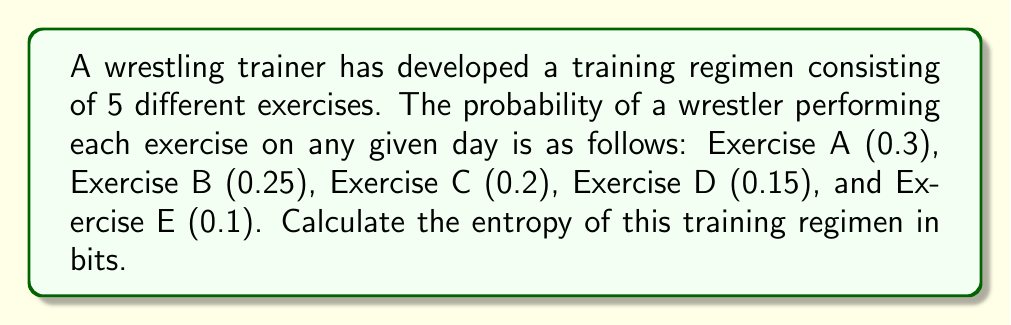Give your solution to this math problem. To calculate the entropy of the training regimen, we'll use the formula for Shannon entropy:

$$ S = -\sum_{i=1}^{n} p_i \log_2(p_i) $$

Where $S$ is the entropy, $p_i$ is the probability of each outcome, and $n$ is the number of possible outcomes.

Step 1: List the probabilities for each exercise:
$p_1 = 0.3$ (Exercise A)
$p_2 = 0.25$ (Exercise B)
$p_3 = 0.2$ (Exercise C)
$p_4 = 0.15$ (Exercise D)
$p_5 = 0.1$ (Exercise E)

Step 2: Calculate $-p_i \log_2(p_i)$ for each exercise:

Exercise A: $-0.3 \log_2(0.3) = 0.3 \times 1.737 = 0.5211$
Exercise B: $-0.25 \log_2(0.25) = 0.25 \times 2 = 0.5000$
Exercise C: $-0.2 \log_2(0.2) = 0.2 \times 2.322 = 0.4644$
Exercise D: $-0.15 \log_2(0.15) = 0.15 \times 2.737 = 0.4106$
Exercise E: $-0.1 \log_2(0.1) = 0.1 \times 3.322 = 0.3322$

Step 3: Sum up all the values to get the entropy:

$S = 0.5211 + 0.5000 + 0.4644 + 0.4106 + 0.3322 = 2.2283$ bits
Answer: 2.2283 bits 